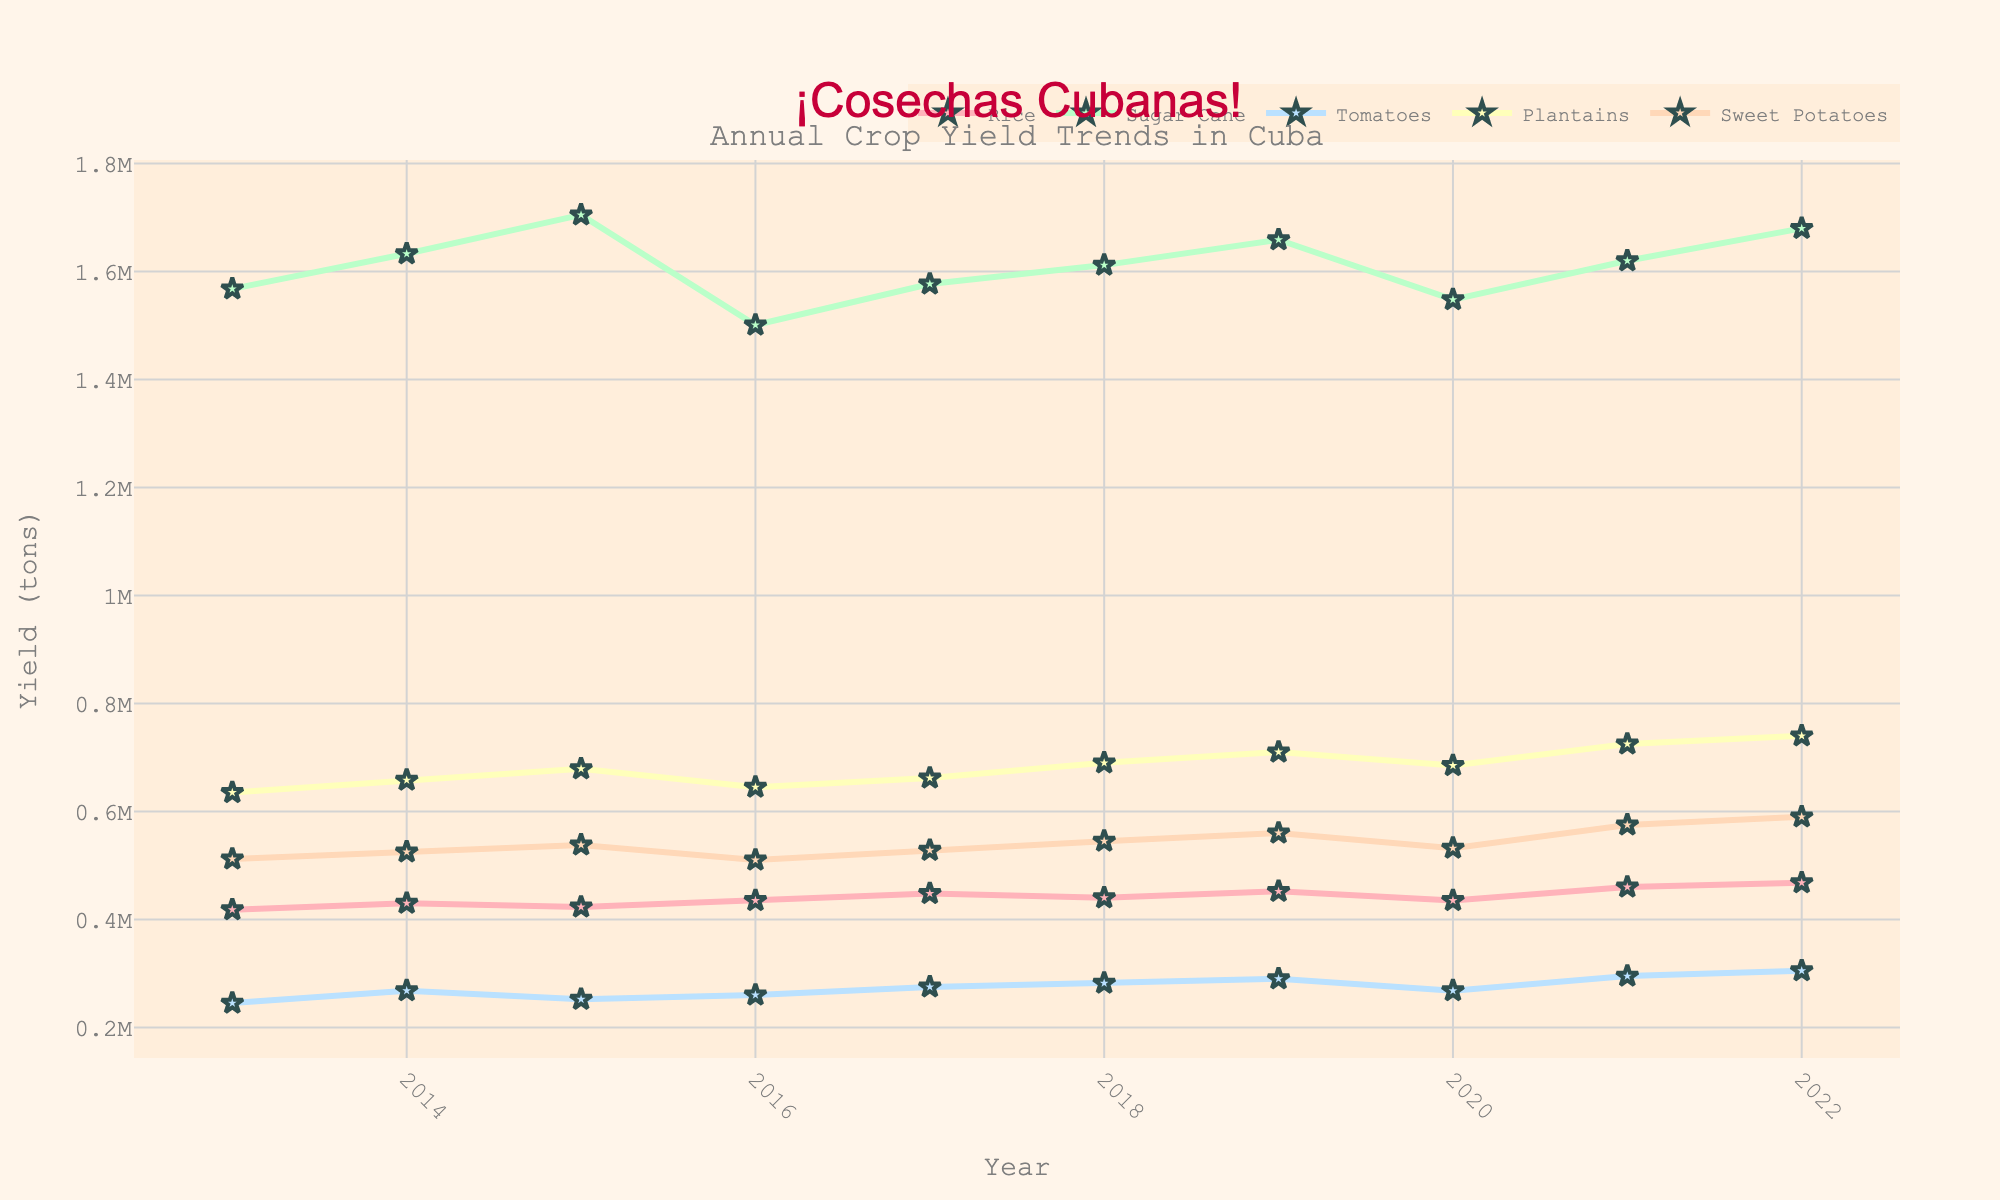What's the trend in rice yield from 2013 to 2022? The rice yield shows a general increase over the years. It started at 418,000 tons in 2013 and reached 468,000 tons in 2022, with some minor fluctuations in between.
Answer: Increasing Which crop had the highest yield in 2017? By examining the y-axis positions for each crop in 2017, the yield of Sugar Cane is the highest, significantly higher than the others.
Answer: Sugar Cane What is the difference in plantain yield between 2014 and 2020? The plantain yield in 2014 is 658,000 tons and in 2020 is 685,000 tons. Calculating the difference, 685,000 - 658,000 = 27,000 tons.
Answer: 27,000 tons Which crop experienced the most significant drop in yield between two consecutive years? Observing the line trends, the most significant drop is seen in Sugar Cane between 2015 (1,705,000 tons) and 2016 (1,501,000 tons), a difference of 204,000 tons.
Answer: Sugar Cane In what year did sweet potatoes yield cross 540,000 tons for the first time? Tracking the line for Sweet Potatoes, it crossed 540,000 tons in 2018 with a yield of 545,000 tons.
Answer: 2018 Calculate the average yield of tomatoes over the decade. Adding the yearly yields from 2013 to 2022: 245,000 + 268,000 + 252,000 + 260,000 + 275,000 + 282,000 + 290,000 + 268,000 + 295,000 + 305,000 = 2,740,000. Dividing by 10 years, the average is 2,740,000 / 10 = 274,000 tons.
Answer: 274,000 tons Compare the yield of rice and sweet potatoes in 2022 and state which was higher. In 2022, the rice yield was 468,000 tons while the sweet potatoes yield was 590,000 tons. Sweet potatoes had a higher yield.
Answer: Sweet Potatoes What color represents the line for tomatoes? The line for tomatoes is represented by a blue color.
Answer: Blue What is the sum of the yields for sugar cane and plantains in 2020? In 2020, the yield for Sugar Cane is 1,548,000 tons and for Plantains is 685,000 tons. Summing these, we get 1,548,000 + 685,000 = 2,233,000 tons.
Answer: 2,233,000 tons What is the visual trend for each of the crops over the decade? Rice and Sweet Potatoes show a general increase. Tomatoes show a slightly increasing trend. Plantains generally increase with minor fluctuations. Sugar Cane has fluctuating trends with a drop around 2016.
Answer: Varied trends 